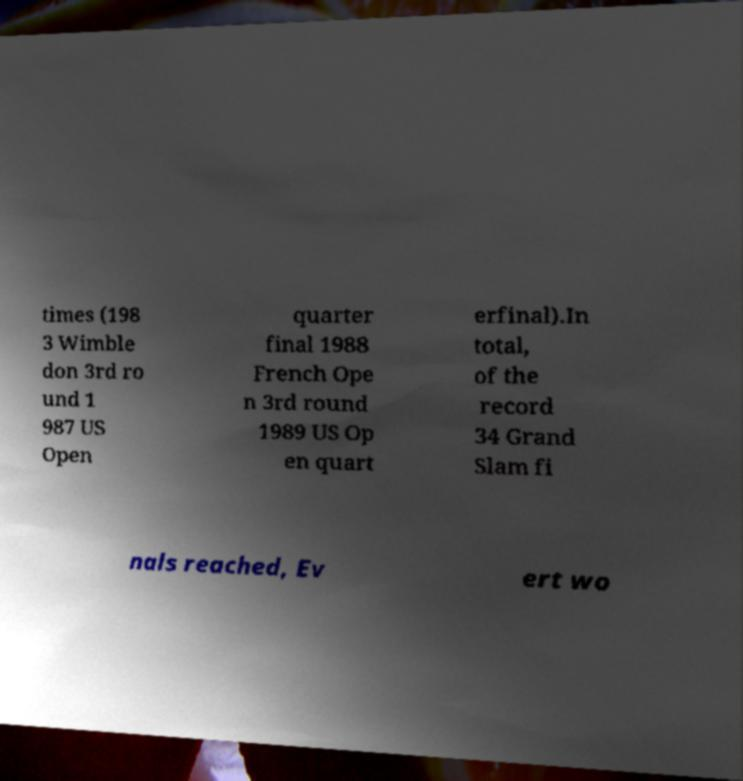Can you accurately transcribe the text from the provided image for me? times (198 3 Wimble don 3rd ro und 1 987 US Open quarter final 1988 French Ope n 3rd round 1989 US Op en quart erfinal).In total, of the record 34 Grand Slam fi nals reached, Ev ert wo 